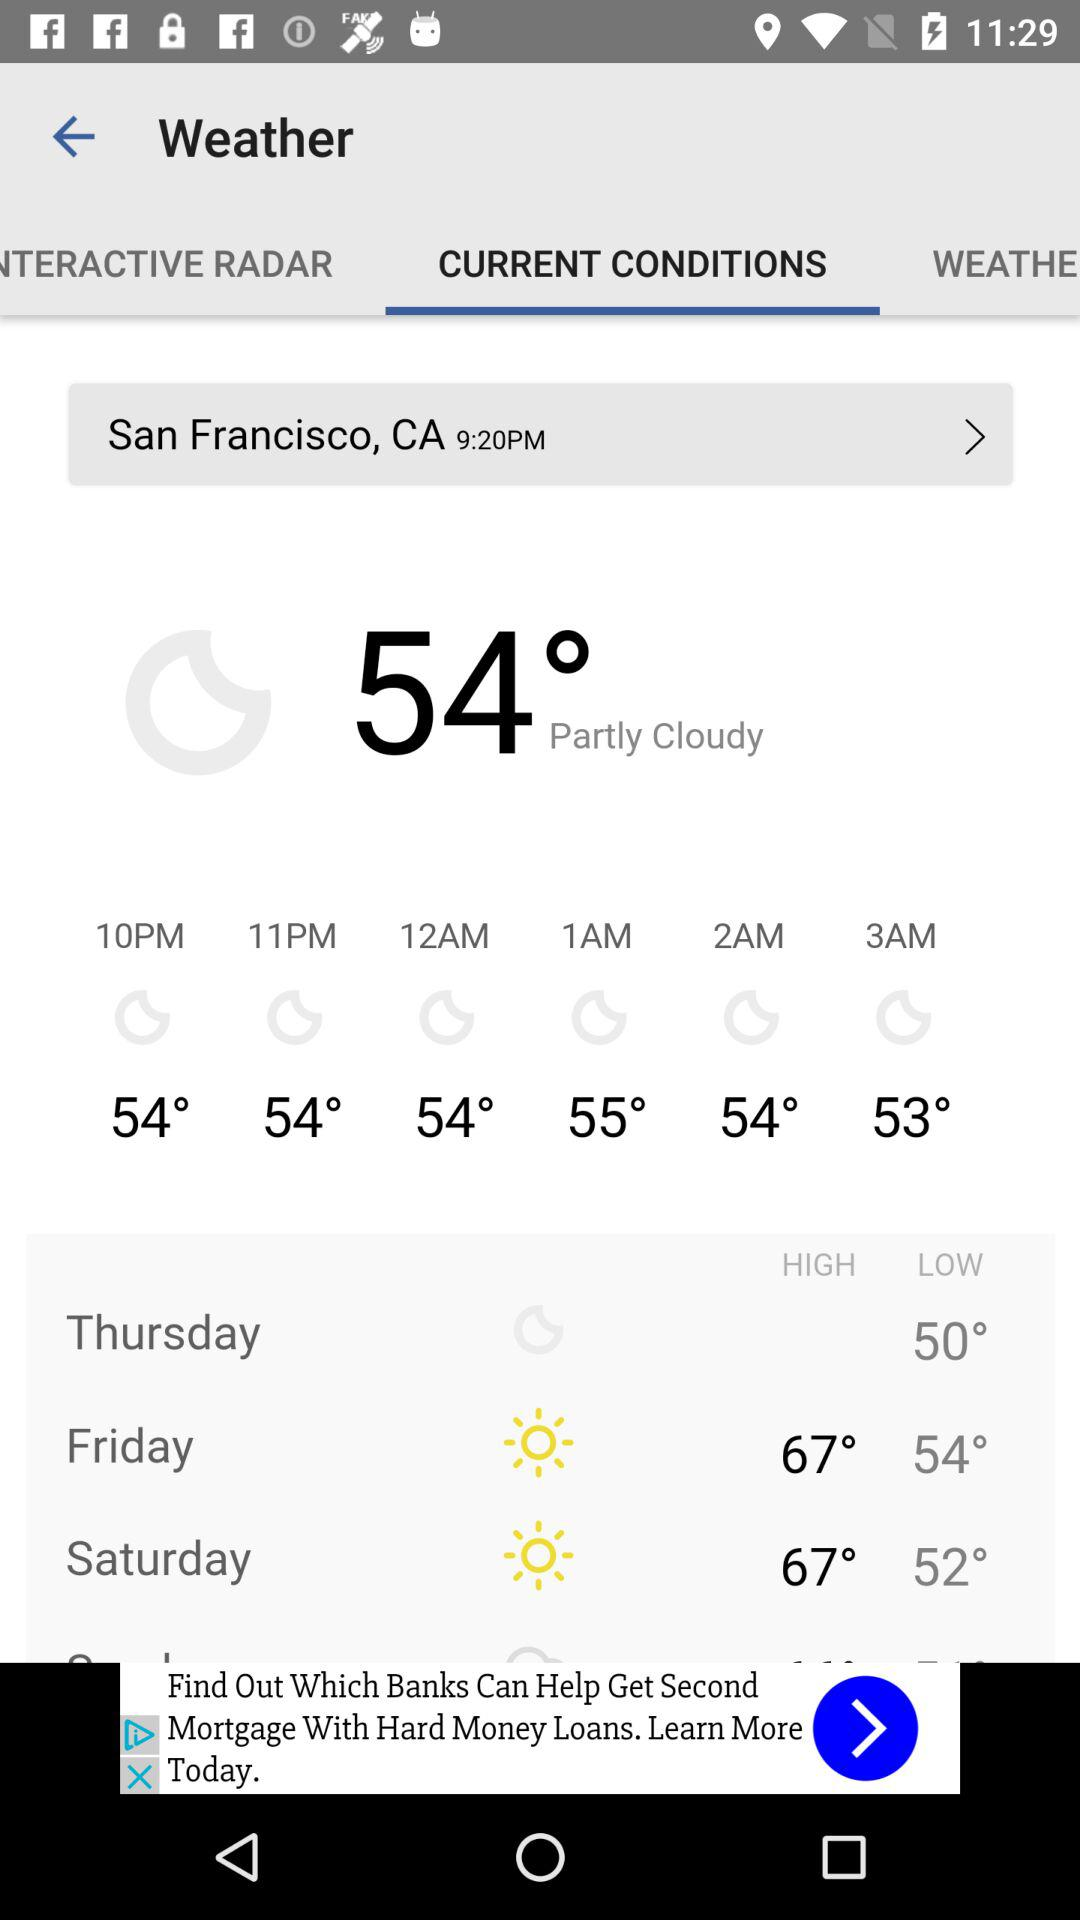What is the location? The location is San Francisco, CA. 